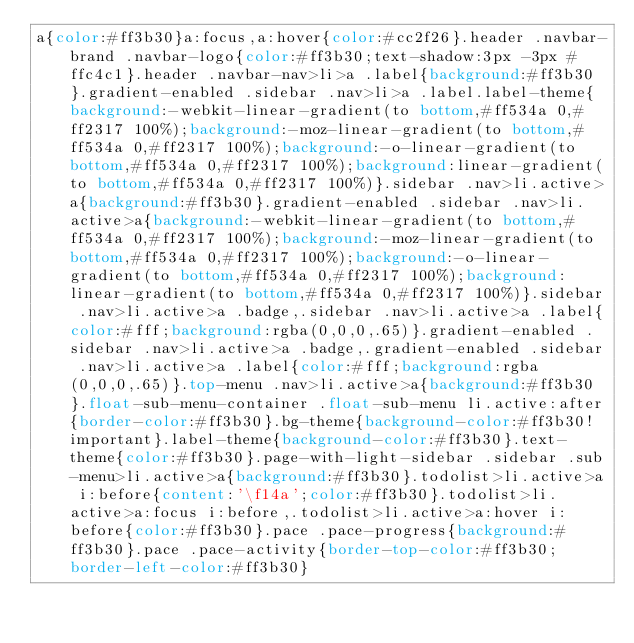Convert code to text. <code><loc_0><loc_0><loc_500><loc_500><_CSS_>a{color:#ff3b30}a:focus,a:hover{color:#cc2f26}.header .navbar-brand .navbar-logo{color:#ff3b30;text-shadow:3px -3px #ffc4c1}.header .navbar-nav>li>a .label{background:#ff3b30}.gradient-enabled .sidebar .nav>li>a .label.label-theme{background:-webkit-linear-gradient(to bottom,#ff534a 0,#ff2317 100%);background:-moz-linear-gradient(to bottom,#ff534a 0,#ff2317 100%);background:-o-linear-gradient(to bottom,#ff534a 0,#ff2317 100%);background:linear-gradient(to bottom,#ff534a 0,#ff2317 100%)}.sidebar .nav>li.active>a{background:#ff3b30}.gradient-enabled .sidebar .nav>li.active>a{background:-webkit-linear-gradient(to bottom,#ff534a 0,#ff2317 100%);background:-moz-linear-gradient(to bottom,#ff534a 0,#ff2317 100%);background:-o-linear-gradient(to bottom,#ff534a 0,#ff2317 100%);background:linear-gradient(to bottom,#ff534a 0,#ff2317 100%)}.sidebar .nav>li.active>a .badge,.sidebar .nav>li.active>a .label{color:#fff;background:rgba(0,0,0,.65)}.gradient-enabled .sidebar .nav>li.active>a .badge,.gradient-enabled .sidebar .nav>li.active>a .label{color:#fff;background:rgba(0,0,0,.65)}.top-menu .nav>li.active>a{background:#ff3b30}.float-sub-menu-container .float-sub-menu li.active:after{border-color:#ff3b30}.bg-theme{background-color:#ff3b30!important}.label-theme{background-color:#ff3b30}.text-theme{color:#ff3b30}.page-with-light-sidebar .sidebar .sub-menu>li.active>a{background:#ff3b30}.todolist>li.active>a i:before{content:'\f14a';color:#ff3b30}.todolist>li.active>a:focus i:before,.todolist>li.active>a:hover i:before{color:#ff3b30}.pace .pace-progress{background:#ff3b30}.pace .pace-activity{border-top-color:#ff3b30;border-left-color:#ff3b30}</code> 